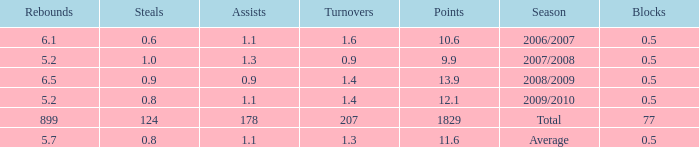What is the maximum rebounds when there are 0.9 steals and fewer than 1.4 turnovers? None. 